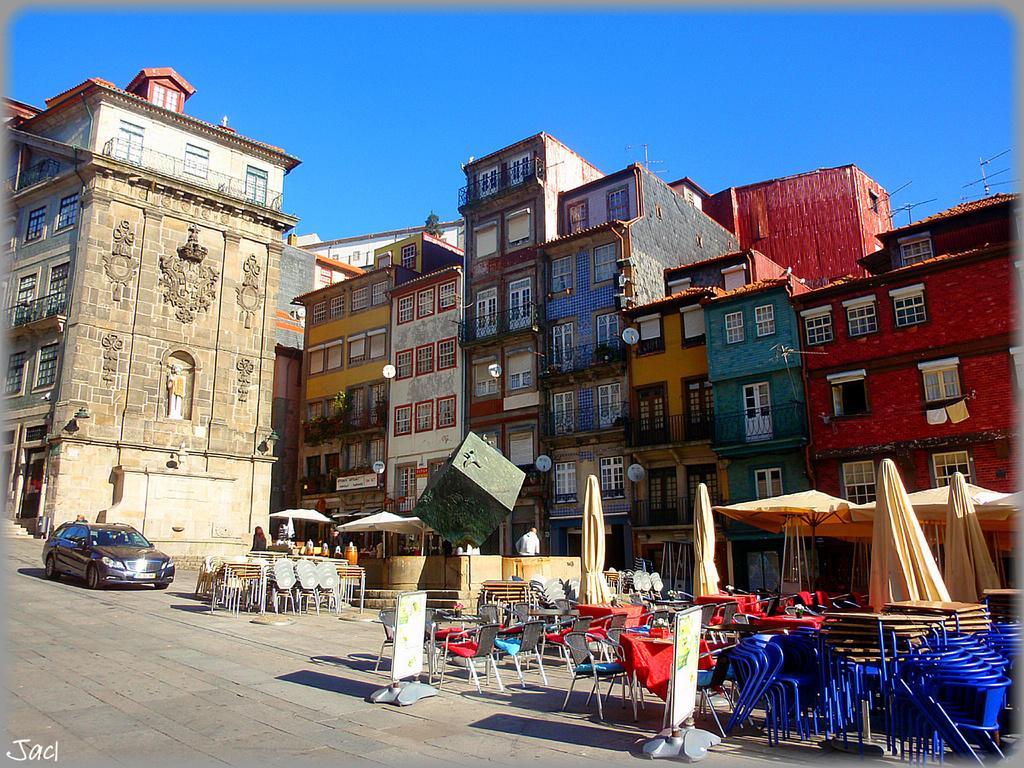In one or two sentences, can you explain what this image depicts? In this picture we can see buildings, at the bottom there are some chairs, tables, umbrellas and boards, on the left side there is a car, we can see windows of these buildings, there are some plants in the middle, we can see the sky at the top of the picture. 